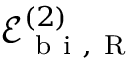Convert formula to latex. <formula><loc_0><loc_0><loc_500><loc_500>\mathcal { E } _ { b i , R } ^ { ( 2 ) }</formula> 